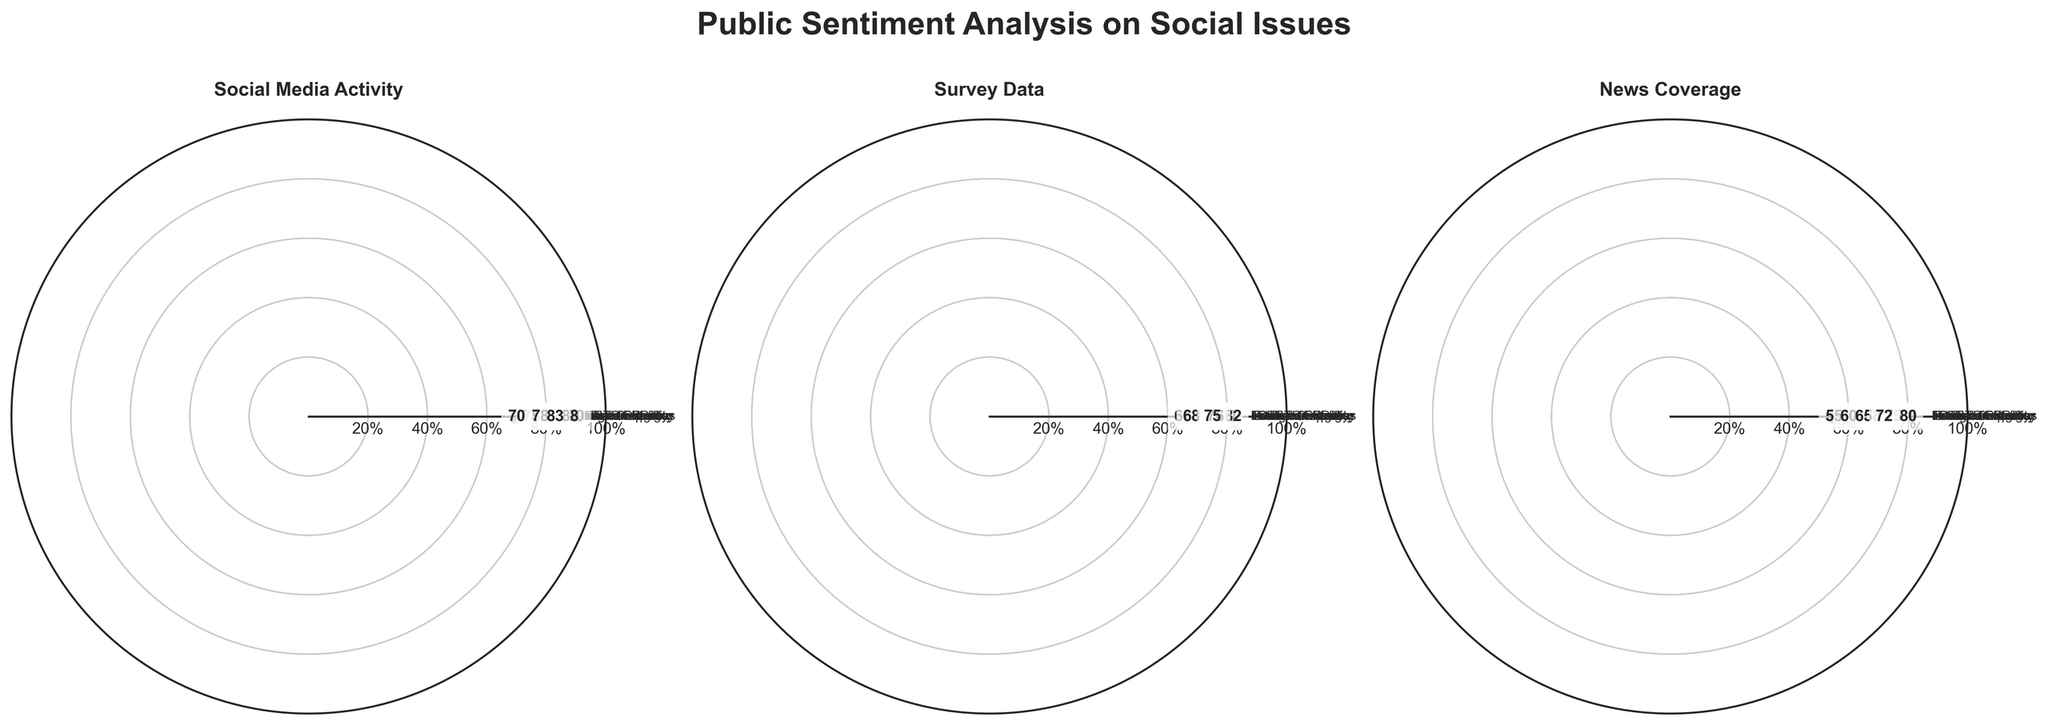Which social issue has the highest public sentiment in Social Media Activity? The radar chart displays comparisons for different social issues. By observing the highest point on the Social Media Activity subplot, we see that Healthcare Access has the highest value at 90.
Answer: Healthcare Access Which social issue has the lowest sentiment according to News Coverage? The subplot titled "News Coverage" shows different values. By identifying the lowest value, we find that Education Reform has the lowest value at 55.
Answer: Education Reform What is the difference in Survey Data sentiment between Gun Control and Gender Equality? The Survey Data subplot indicates the values for each category. Gun Control has a value of 82 while Gender Equality has a value of 76. The difference is calculated as 82 - 76.
Answer: 6 What is the average sentiment value across all social issues in the Social Media Activity subplot? On the Social Media Activity subplot, list all values (85, 90, 75, 82, 78, 70, 88, 83). Sum these values (651) and divide by the number of data points (8) to get the average: 651/8.
Answer: 81.375 Compare the Survey Data sentiment of Climate Change with that of Immigration Policy. Which one is higher? Observing the Survey Data subplot, we see that Climate Change has a value of 77 and Immigration Policy has a value of 68. Thus, Climate Change has a higher sentiment in this category.
Answer: Climate Change Which social issue shows the highest variance in sentiment across the three measurement categories? To find the variance, we observe the differences in sentiment values for each issue in all subplots. By visually comparing the ranges, Education Reform shows the highest variance with values 75 (Social Media Activity), 65 (Survey Data), and 55 (News Coverage).
Answer: Education Reform Is there any social issue with the same sentiment value in at least two measurement categories? Scan through each social issue to find matching values in at least two categories. By inspection, there is no social issue that has identical sentiment values across even two categories.
Answer: No What is the total sentiment score for Gender Equality across all measurement categories? By summing up the values for Gender Equality in Social Media Activity (88), Survey Data (76), and News Coverage (80): 88 + 76 + 80 = 244.
Answer: 244 